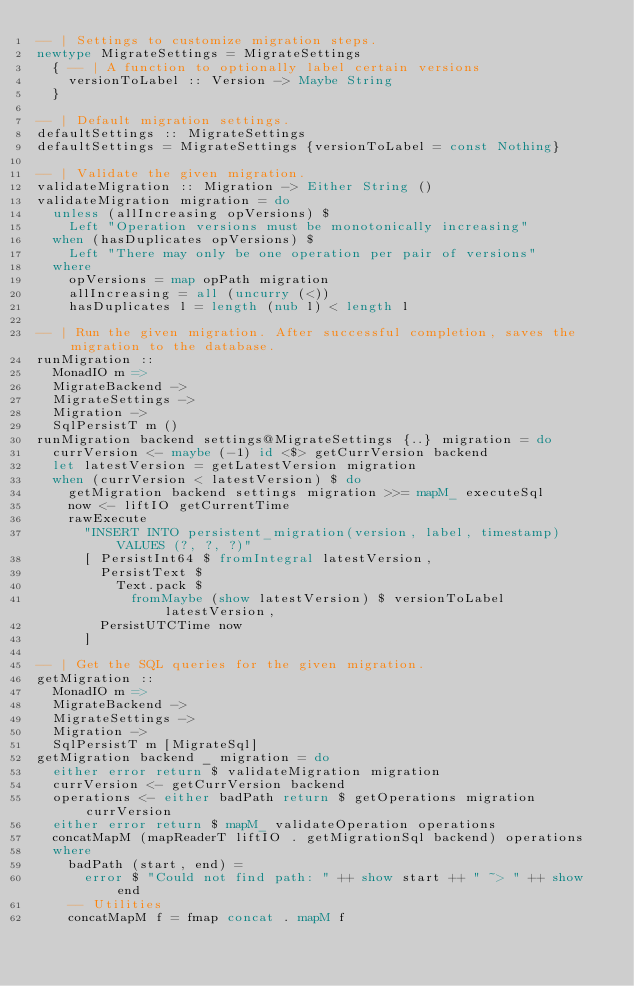<code> <loc_0><loc_0><loc_500><loc_500><_Haskell_>-- | Settings to customize migration steps.
newtype MigrateSettings = MigrateSettings
  { -- | A function to optionally label certain versions
    versionToLabel :: Version -> Maybe String
  }

-- | Default migration settings.
defaultSettings :: MigrateSettings
defaultSettings = MigrateSettings {versionToLabel = const Nothing}

-- | Validate the given migration.
validateMigration :: Migration -> Either String ()
validateMigration migration = do
  unless (allIncreasing opVersions) $
    Left "Operation versions must be monotonically increasing"
  when (hasDuplicates opVersions) $
    Left "There may only be one operation per pair of versions"
  where
    opVersions = map opPath migration
    allIncreasing = all (uncurry (<))
    hasDuplicates l = length (nub l) < length l

-- | Run the given migration. After successful completion, saves the migration to the database.
runMigration ::
  MonadIO m =>
  MigrateBackend ->
  MigrateSettings ->
  Migration ->
  SqlPersistT m ()
runMigration backend settings@MigrateSettings {..} migration = do
  currVersion <- maybe (-1) id <$> getCurrVersion backend
  let latestVersion = getLatestVersion migration
  when (currVersion < latestVersion) $ do
    getMigration backend settings migration >>= mapM_ executeSql
    now <- liftIO getCurrentTime
    rawExecute
      "INSERT INTO persistent_migration(version, label, timestamp) VALUES (?, ?, ?)"
      [ PersistInt64 $ fromIntegral latestVersion,
        PersistText $
          Text.pack $
            fromMaybe (show latestVersion) $ versionToLabel latestVersion,
        PersistUTCTime now
      ]

-- | Get the SQL queries for the given migration.
getMigration ::
  MonadIO m =>
  MigrateBackend ->
  MigrateSettings ->
  Migration ->
  SqlPersistT m [MigrateSql]
getMigration backend _ migration = do
  either error return $ validateMigration migration
  currVersion <- getCurrVersion backend
  operations <- either badPath return $ getOperations migration currVersion
  either error return $ mapM_ validateOperation operations
  concatMapM (mapReaderT liftIO . getMigrationSql backend) operations
  where
    badPath (start, end) =
      error $ "Could not find path: " ++ show start ++ " ~> " ++ show end
    -- Utilities
    concatMapM f = fmap concat . mapM f
</code> 